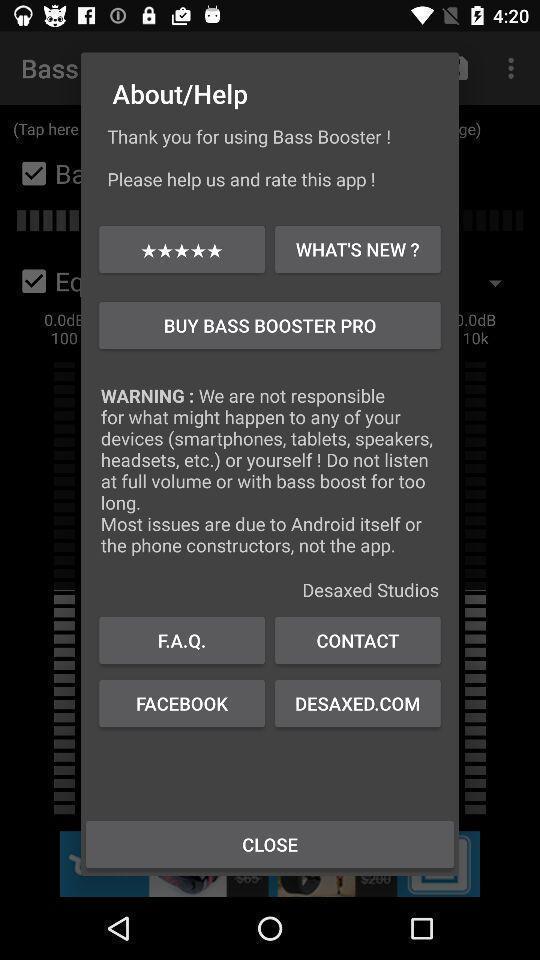What is the overall content of this screenshot? Pop-up displaying help page. 